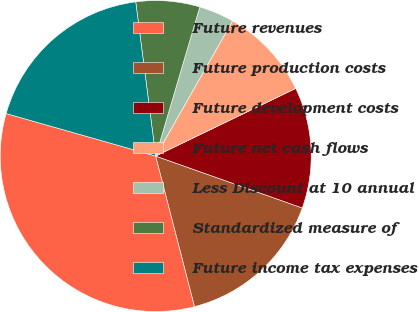Convert chart to OTSL. <chart><loc_0><loc_0><loc_500><loc_500><pie_chart><fcel>Future revenues<fcel>Future production costs<fcel>Future development costs<fcel>Future net cash flows<fcel>Less Discount at 10 annual<fcel>Standardized measure of<fcel>Future income tax expenses<nl><fcel>33.43%<fcel>15.56%<fcel>12.58%<fcel>9.61%<fcel>3.65%<fcel>6.63%<fcel>18.54%<nl></chart> 